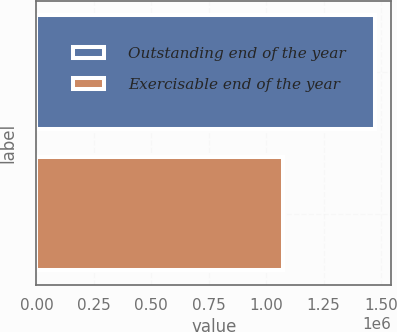Convert chart. <chart><loc_0><loc_0><loc_500><loc_500><bar_chart><fcel>Outstanding end of the year<fcel>Exercisable end of the year<nl><fcel>1.47145e+06<fcel>1.0732e+06<nl></chart> 